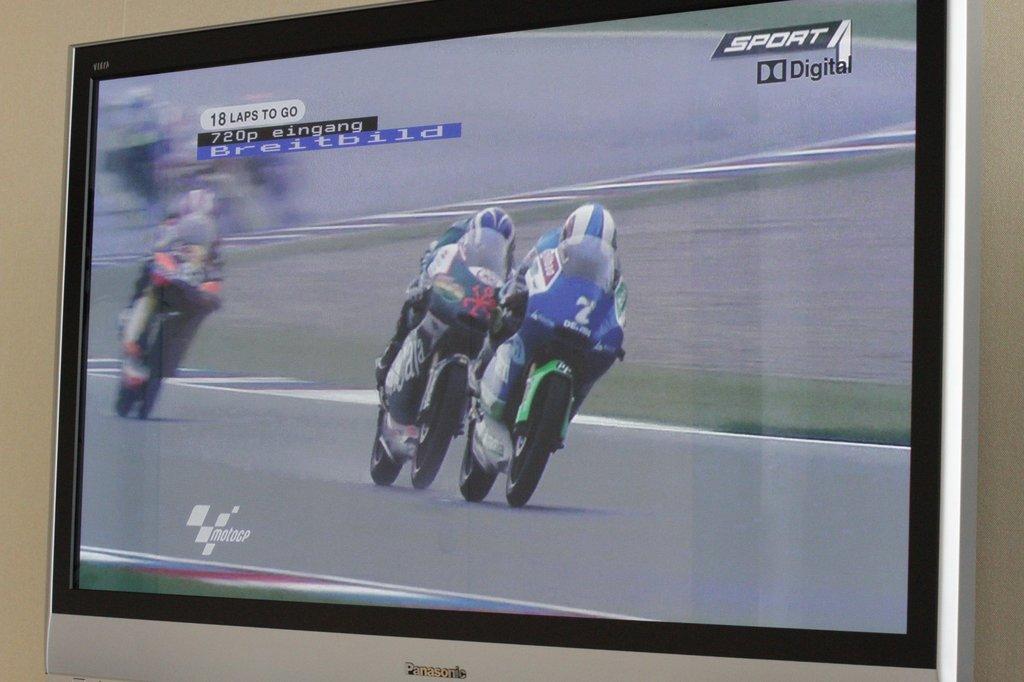How many laps to go?
Ensure brevity in your answer.  18. What dies it say on the top right of the screen?
Provide a succinct answer. Sport digital. 